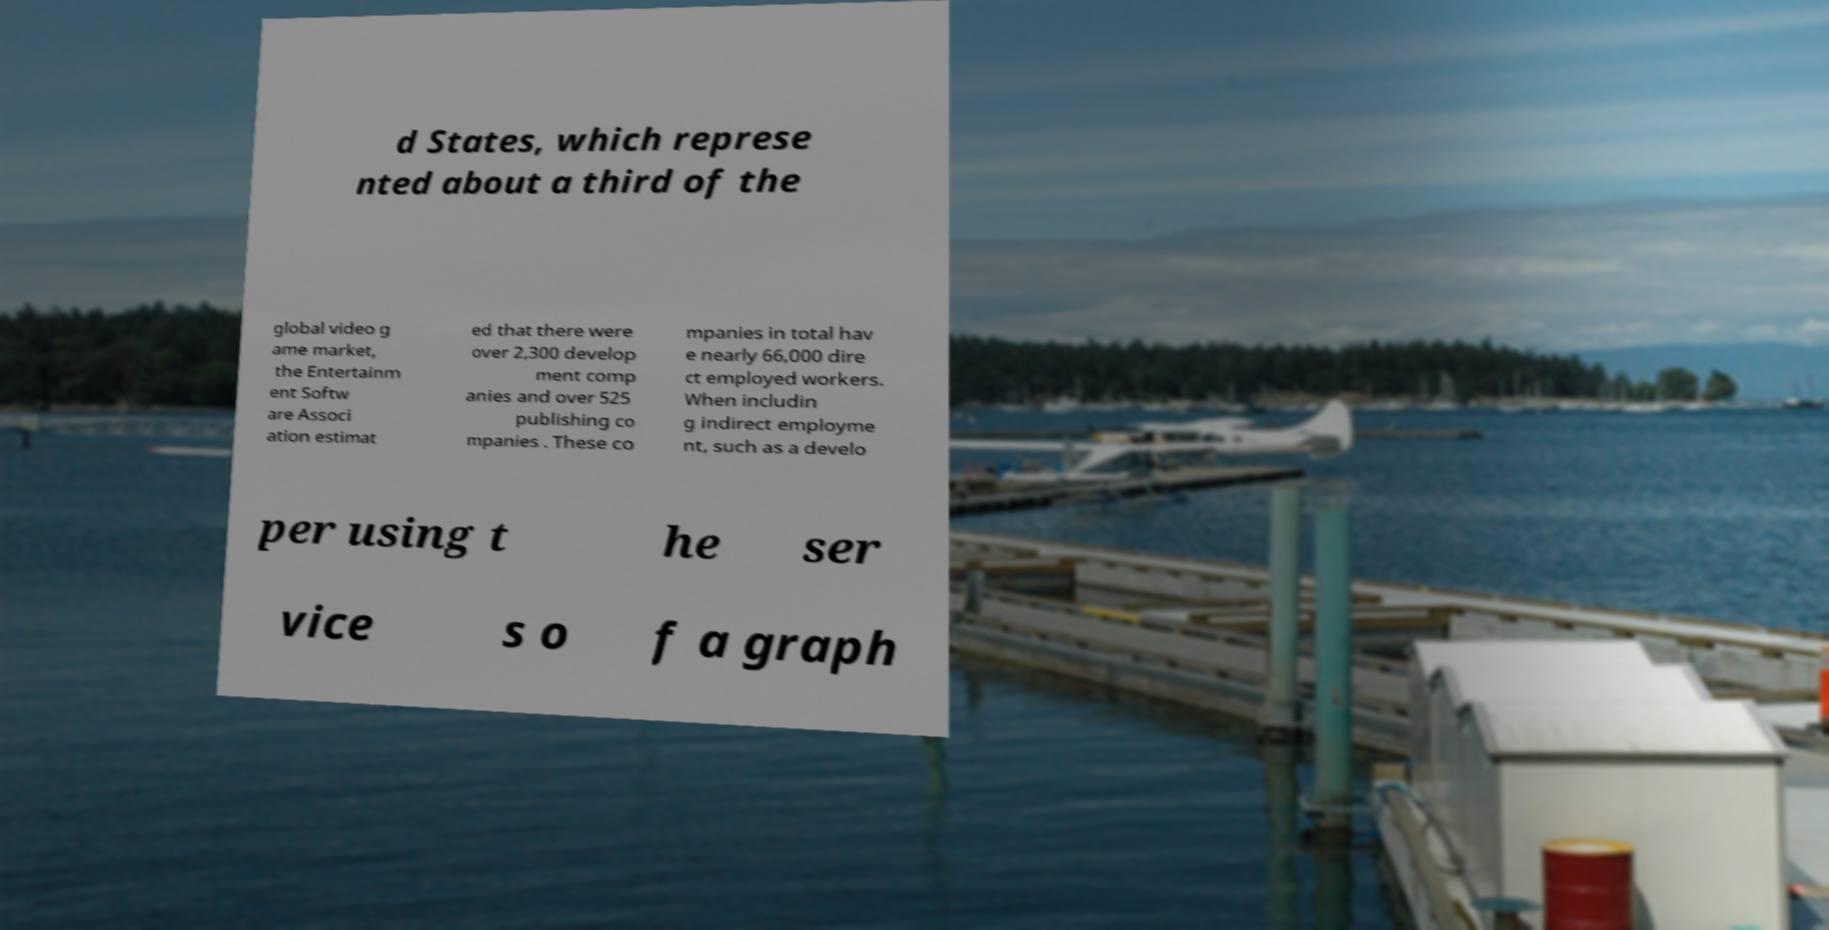Please identify and transcribe the text found in this image. d States, which represe nted about a third of the global video g ame market, the Entertainm ent Softw are Associ ation estimat ed that there were over 2,300 develop ment comp anies and over 525 publishing co mpanies . These co mpanies in total hav e nearly 66,000 dire ct employed workers. When includin g indirect employme nt, such as a develo per using t he ser vice s o f a graph 